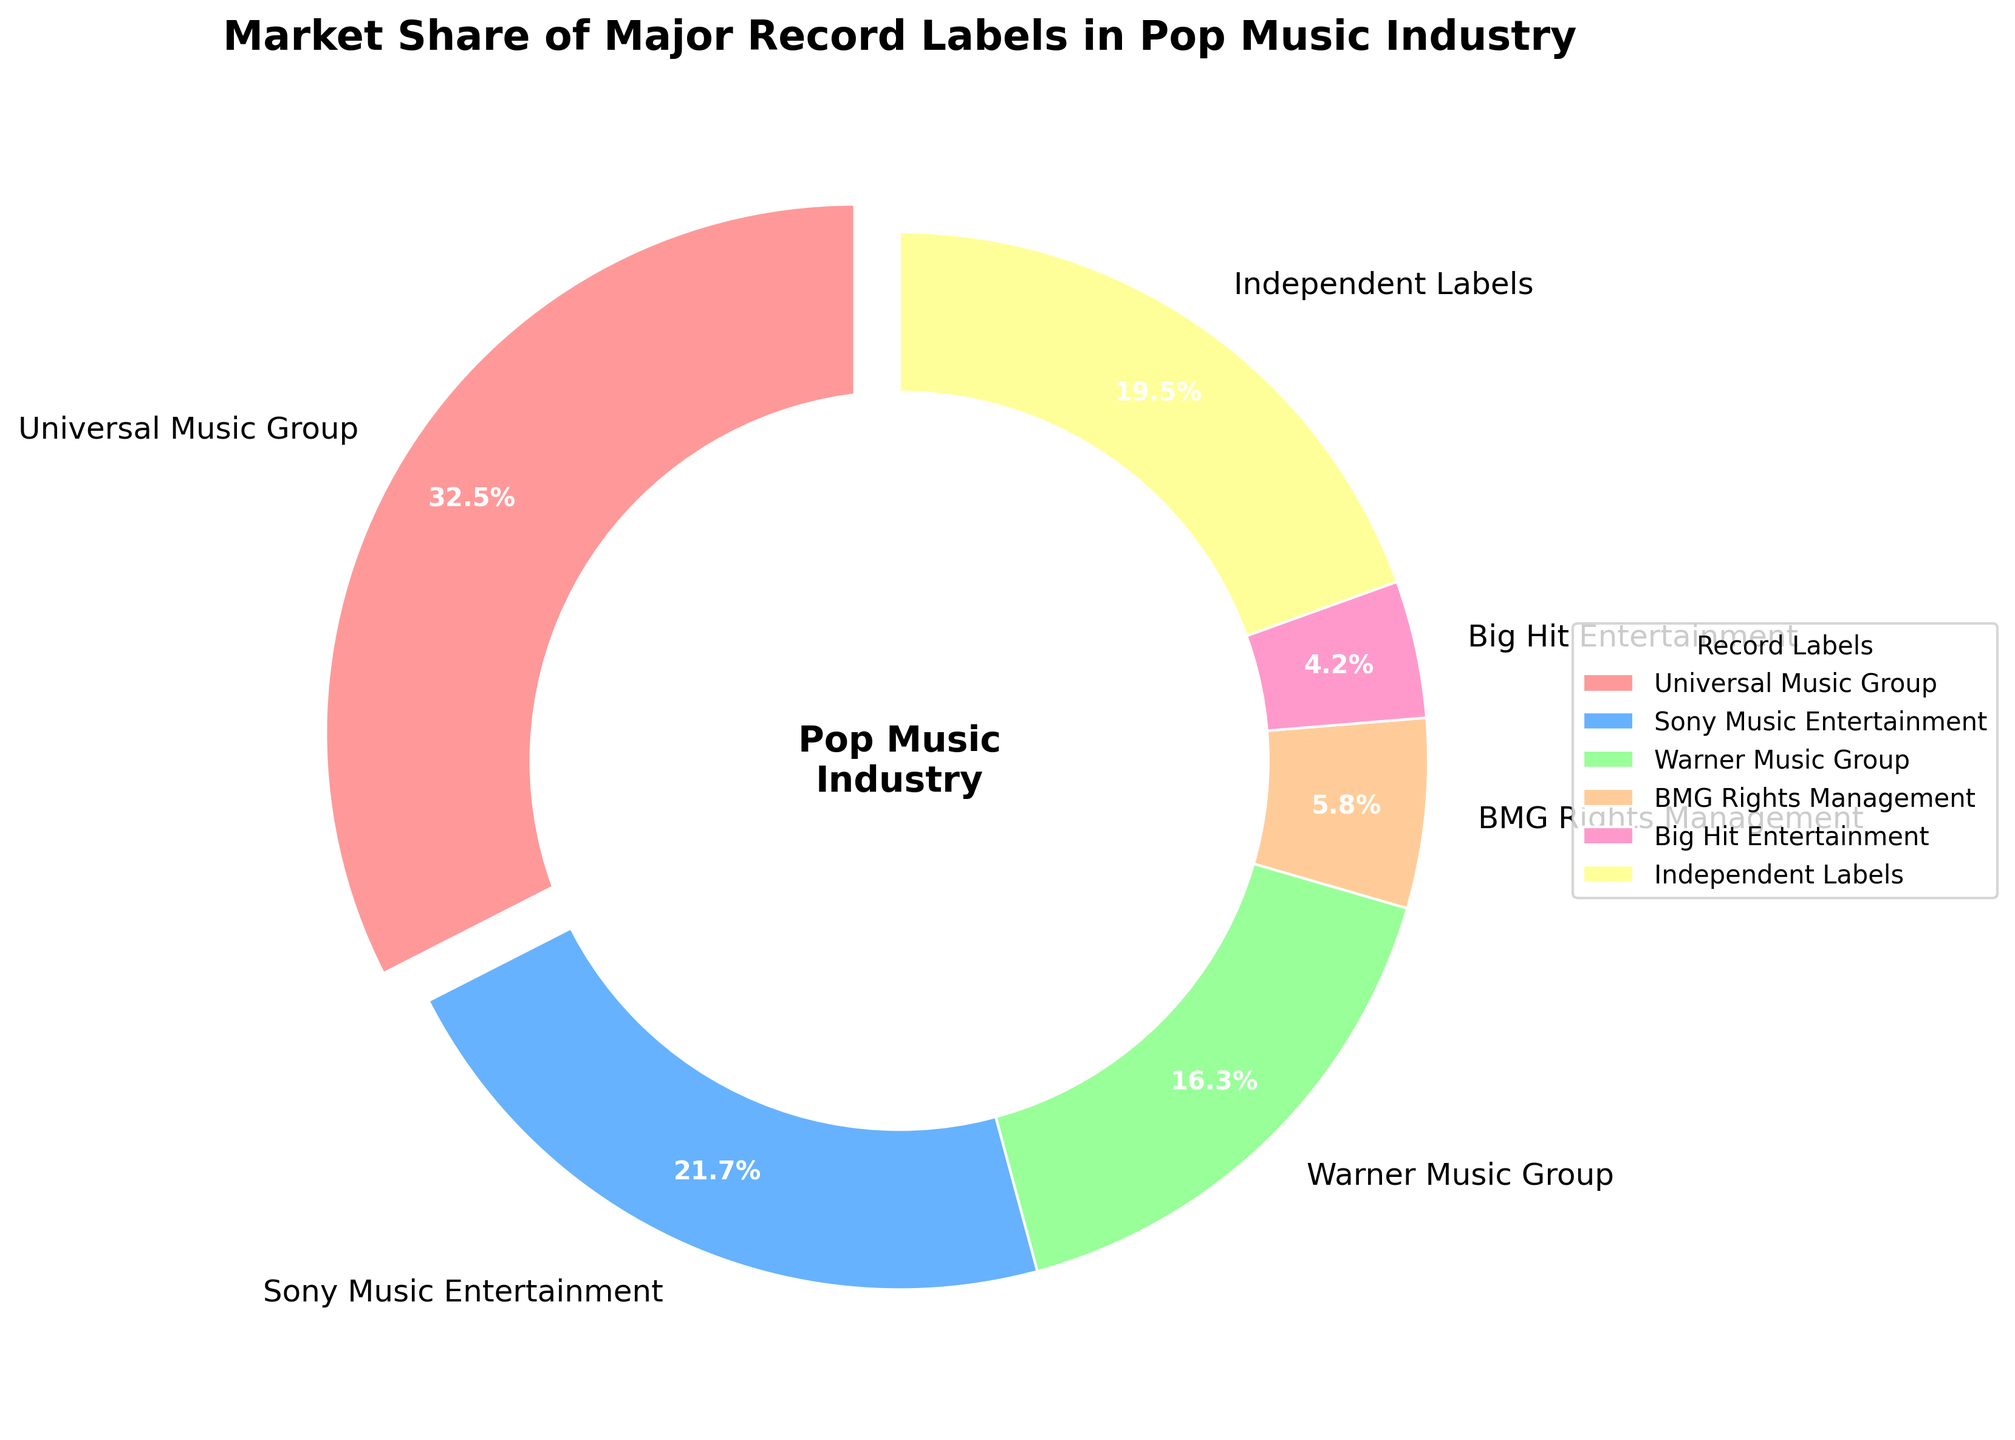Which record label has the largest market share? The wedge that is slightly exploded and has a label with a higher percentage value indicates the largest market share. By checking all percentages, Universal Music Group has the largest share with 32.5%.
Answer: Universal Music Group Which two record labels combined have a market share close to that of Universal Music Group? By identifying the second and third highest market shares, Sony Music Entertainment (21.7%) and Warner Music Group (16.3%) combined equal 38%, which is slightly higher than Universal Music Group’s 32.5%.
Answer: Sony Music Entertainment and Warner Music Group How much greater is Universal Music Group's market share compared to Warner Music Group's market share? Subtract Warner Music Group's market share (16.3%) from Universal Music Group's market share (32.5%). 32.5% - 16.3% = 16.2%. Universal Music Group's market share is 16.2% greater than Warner Music Group's.
Answer: 16.2% Which record label has a market share slightly higher than Big Hit Entertainment but lower than BMG Rights Management? Compare the slices by their position and percentage. Big Hit Entertainment has 4.2% and BMG Rights Management has 5.8%. Independent Labels have 19.5%, which is higher, hence the label with 5.8% is BMG Rights Management. There’s no label with a share slightly higher than Big Hit Entertainment and lower than BMG Rights Management. Only BMG Rights Management has a single share in between.
Answer: None Calculate the total market share of all independent labels combined with BMG Rights Management. Add the percentages of Independent Labels (19.5%) and BMG Rights Management (5.8%). 19.5% + 5.8% = 25.3%
Answer: 25.3% What color represents Sony Music Entertainment on the pie chart? Observe the pie chart and match the labels with their corresponding colors. Sony Music Entertainment is represented by the blue section.
Answer: Blue Which label has the smallest market share, and what percentage is it? The smallest slice corresponds to the smallest percentage. The label Big Hit Entertainment shows 4.2%, smaller than the other shares in the pie chart.
Answer: Big Hit Entertainment, 4.2% How does the market share of Independent Labels compare to that of Sony Music Entertainment? Compare the slices visually or numerically. Independent Labels have a market share of 19.5%, whereas Sony Music Entertainment's share is 21.7%. Sony Music Entertainment's market share is larger.
Answer: Sony Music Entertainment has a greater share What is the total percentage share of the three largest record labels? Sum the market shares of Universal Music Group (32.5%), Sony Music Entertainment (21.7%), and Warner Music Group (16.3%). 32.5% + 21.7% + 16.3% = 70.5%
Answer: 70.5% 